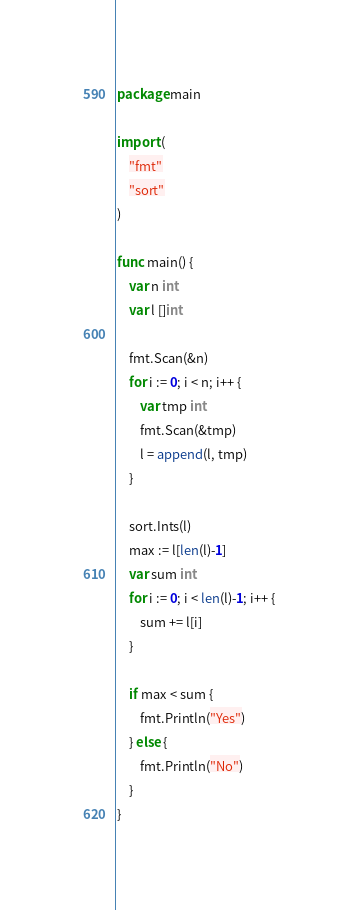<code> <loc_0><loc_0><loc_500><loc_500><_Go_>package main

import (
	"fmt"
	"sort"
)

func main() {
	var n int
	var l []int

	fmt.Scan(&n)
	for i := 0; i < n; i++ {
		var tmp int
		fmt.Scan(&tmp)
		l = append(l, tmp)
	}

	sort.Ints(l)
	max := l[len(l)-1]
	var sum int
	for i := 0; i < len(l)-1; i++ {
		sum += l[i]
	}

	if max < sum {
		fmt.Println("Yes")
	} else {
		fmt.Println("No")
	}
}
</code> 